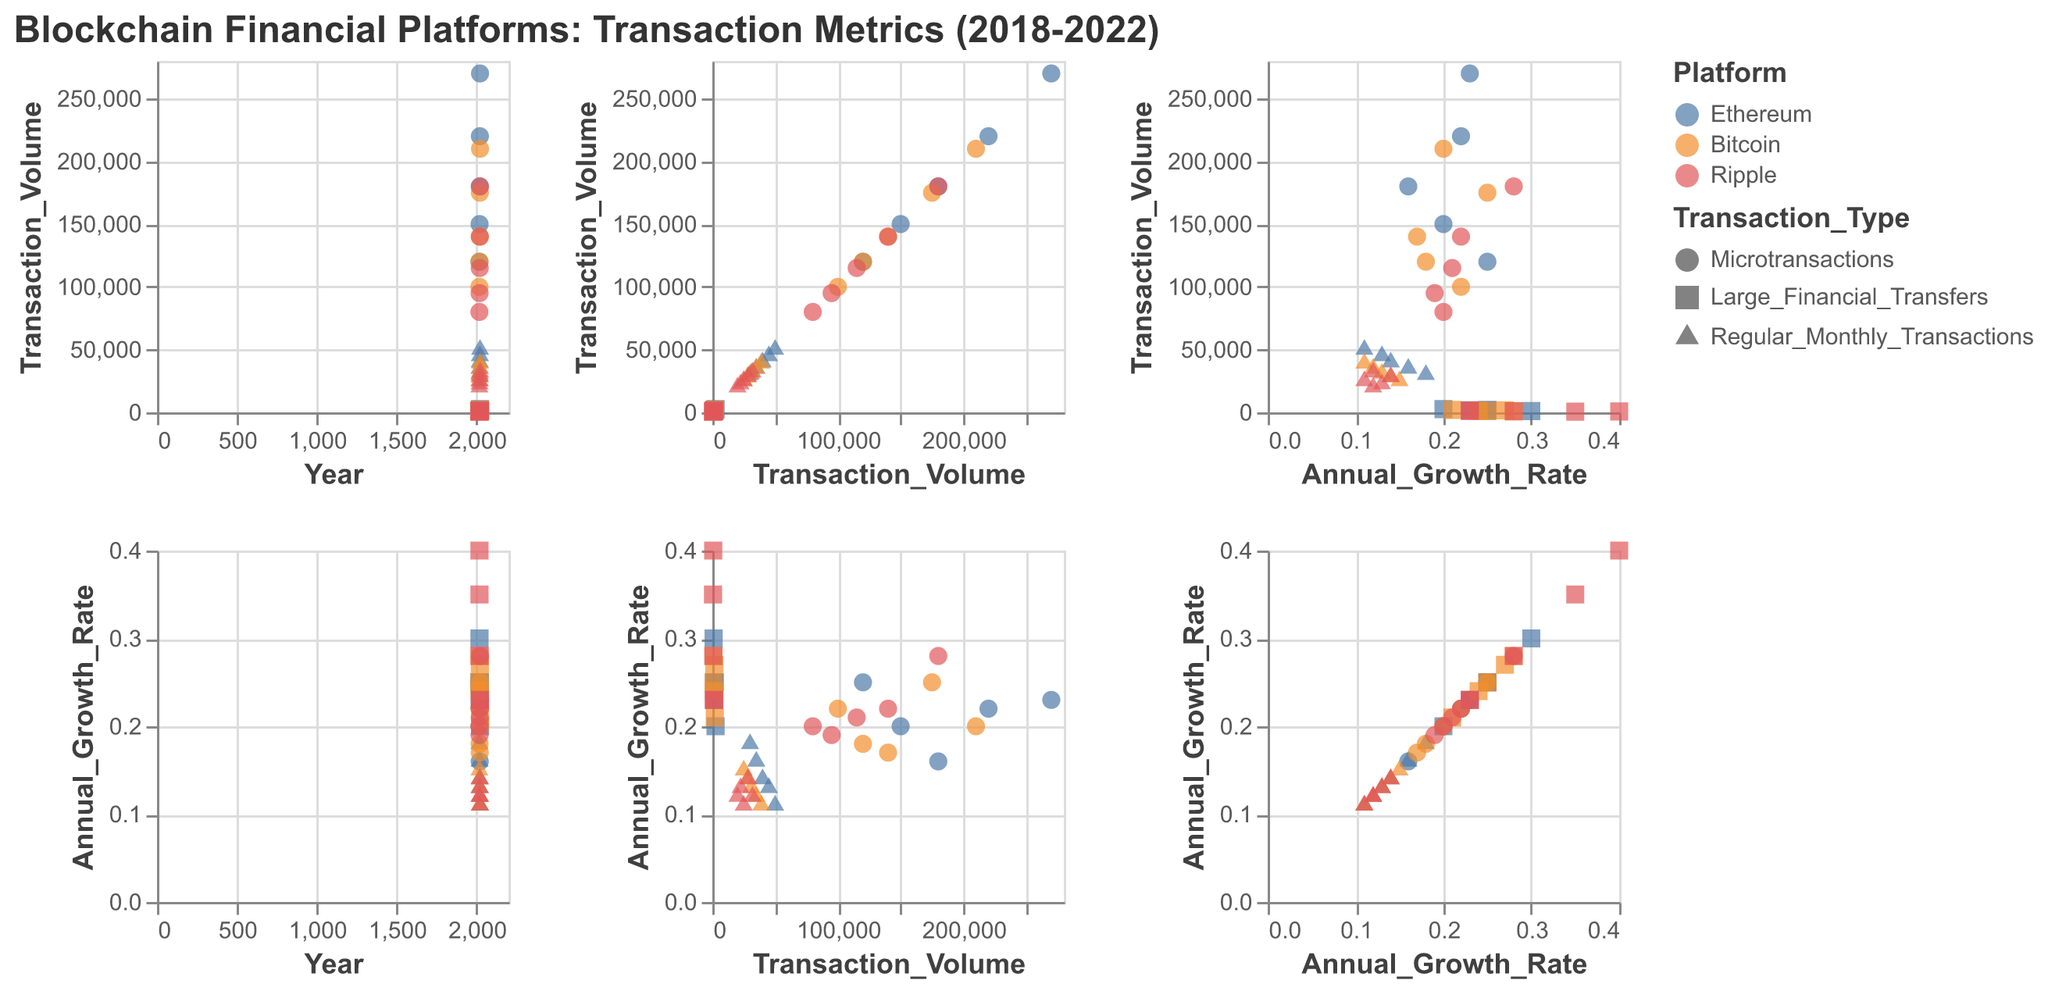What's the title of the figure? The title of the figure is placed at the top of the visual and states the main subject and the time period covered by the data.
Answer: Blockchain Financial Platforms: Transaction Metrics (2018-2022) What are the platforms depicted in the scatter plot matrix? The platforms are differentiated by color in the matrix, and the legend indicates which colors correspond to each platform.
Answer: Ethereum, Bitcoin, Ripple Which transaction type has the highest volume in 2022 for Ethereum? By examining the points for Ethereum in 2022 and checking their labels corresponding to each transaction type, you notice that microtransactions have the highest volume.
Answer: Microtransactions How has the transaction volume for Bitcoin's microtransactions changed over the years? Track the points corresponding to Bitcoin's microtransactions over the years and observe the increase in volume for each year from 2018 to 2022.
Answer: Increased Between Ethereum and Ripple, which has a higher annual growth rate for large financial transfers in 2020? Compare the points representing large financial transfers for Ethereum and Ripple in 2020 and look at the y-axis for annual growth rate.
Answer: Ethereum What general trend can be observed in the annual growth rates of regular monthly transactions across all platforms? Look at the scatter plots for regular monthly transactions across all years and platforms, and note that the annual growth rates tend to decline over time.
Answer: Decline Which platform consistently has the highest volume for large financial transfers from 2018 to 2022? Examine the points for large financial transfers across all years and platforms, noting that Ethereum consistently has higher volumes compared to Bitcoin and Ripple.
Answer: Ethereum Are there any noticeable outliers in the transaction volumes for Ripple's microtransactions? By scanning the scatter plots, you observe that Ripple's microtransactions in 2022 have a notably higher volume compared to other years.
Answer: Yes, in 2022 What shapes are used to differentiate transaction types in the scatter plot matrix? The legend indicates the shapes used for each transaction type: circle for microtransactions, square for large financial transfers, and triangle for regular monthly transactions.
Answer: Circle, square, triangle How does the annual growth rate in Ethereum's microtransactions in 2020 compare with 2021? By comparing points representing Ethereum's microtransactions in 2020 and 2021, you see that the growth rate was lower in 2020 (0.16) than in 2021 (0.22).
Answer: Lower in 2020 